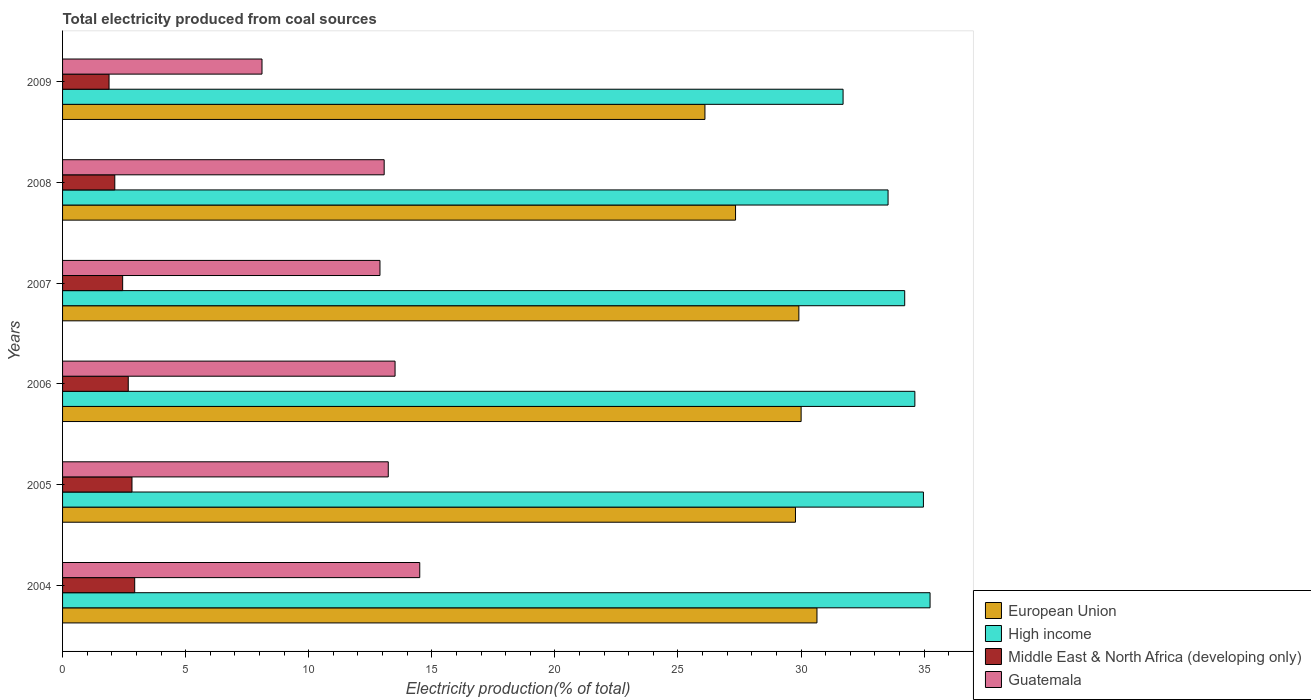Are the number of bars per tick equal to the number of legend labels?
Make the answer very short. Yes. Are the number of bars on each tick of the Y-axis equal?
Keep it short and to the point. Yes. How many bars are there on the 1st tick from the top?
Your answer should be very brief. 4. What is the label of the 3rd group of bars from the top?
Provide a short and direct response. 2007. What is the total electricity produced in European Union in 2009?
Ensure brevity in your answer.  26.1. Across all years, what is the maximum total electricity produced in Middle East & North Africa (developing only)?
Your answer should be compact. 2.93. Across all years, what is the minimum total electricity produced in High income?
Ensure brevity in your answer.  31.71. In which year was the total electricity produced in Guatemala minimum?
Ensure brevity in your answer.  2009. What is the total total electricity produced in Middle East & North Africa (developing only) in the graph?
Make the answer very short. 14.87. What is the difference between the total electricity produced in European Union in 2007 and that in 2009?
Keep it short and to the point. 3.82. What is the difference between the total electricity produced in High income in 2004 and the total electricity produced in European Union in 2005?
Provide a succinct answer. 5.47. What is the average total electricity produced in Middle East & North Africa (developing only) per year?
Your answer should be compact. 2.48. In the year 2008, what is the difference between the total electricity produced in European Union and total electricity produced in Middle East & North Africa (developing only)?
Your response must be concise. 25.22. In how many years, is the total electricity produced in High income greater than 17 %?
Keep it short and to the point. 6. What is the ratio of the total electricity produced in Guatemala in 2006 to that in 2007?
Make the answer very short. 1.05. What is the difference between the highest and the second highest total electricity produced in European Union?
Make the answer very short. 0.64. What is the difference between the highest and the lowest total electricity produced in European Union?
Offer a terse response. 4.55. Is the sum of the total electricity produced in Middle East & North Africa (developing only) in 2004 and 2005 greater than the maximum total electricity produced in Guatemala across all years?
Keep it short and to the point. No. How many years are there in the graph?
Ensure brevity in your answer.  6. Does the graph contain any zero values?
Provide a short and direct response. No. Where does the legend appear in the graph?
Your response must be concise. Bottom right. How many legend labels are there?
Your answer should be compact. 4. How are the legend labels stacked?
Your answer should be very brief. Vertical. What is the title of the graph?
Make the answer very short. Total electricity produced from coal sources. Does "Bermuda" appear as one of the legend labels in the graph?
Your response must be concise. No. What is the Electricity production(% of total) of European Union in 2004?
Ensure brevity in your answer.  30.65. What is the Electricity production(% of total) of High income in 2004?
Your answer should be very brief. 35.24. What is the Electricity production(% of total) in Middle East & North Africa (developing only) in 2004?
Offer a very short reply. 2.93. What is the Electricity production(% of total) of Guatemala in 2004?
Provide a short and direct response. 14.51. What is the Electricity production(% of total) of European Union in 2005?
Give a very brief answer. 29.77. What is the Electricity production(% of total) of High income in 2005?
Give a very brief answer. 34.97. What is the Electricity production(% of total) in Middle East & North Africa (developing only) in 2005?
Provide a short and direct response. 2.82. What is the Electricity production(% of total) of Guatemala in 2005?
Keep it short and to the point. 13.23. What is the Electricity production(% of total) in European Union in 2006?
Make the answer very short. 30. What is the Electricity production(% of total) of High income in 2006?
Give a very brief answer. 34.62. What is the Electricity production(% of total) in Middle East & North Africa (developing only) in 2006?
Keep it short and to the point. 2.67. What is the Electricity production(% of total) in Guatemala in 2006?
Offer a terse response. 13.51. What is the Electricity production(% of total) of European Union in 2007?
Your response must be concise. 29.91. What is the Electricity production(% of total) of High income in 2007?
Make the answer very short. 34.21. What is the Electricity production(% of total) in Middle East & North Africa (developing only) in 2007?
Give a very brief answer. 2.44. What is the Electricity production(% of total) in Guatemala in 2007?
Your response must be concise. 12.89. What is the Electricity production(% of total) of European Union in 2008?
Provide a short and direct response. 27.34. What is the Electricity production(% of total) of High income in 2008?
Make the answer very short. 33.54. What is the Electricity production(% of total) of Middle East & North Africa (developing only) in 2008?
Give a very brief answer. 2.12. What is the Electricity production(% of total) in Guatemala in 2008?
Offer a very short reply. 13.06. What is the Electricity production(% of total) in European Union in 2009?
Ensure brevity in your answer.  26.1. What is the Electricity production(% of total) in High income in 2009?
Offer a very short reply. 31.71. What is the Electricity production(% of total) in Middle East & North Africa (developing only) in 2009?
Offer a terse response. 1.89. What is the Electricity production(% of total) of Guatemala in 2009?
Give a very brief answer. 8.1. Across all years, what is the maximum Electricity production(% of total) of European Union?
Keep it short and to the point. 30.65. Across all years, what is the maximum Electricity production(% of total) of High income?
Provide a short and direct response. 35.24. Across all years, what is the maximum Electricity production(% of total) in Middle East & North Africa (developing only)?
Provide a short and direct response. 2.93. Across all years, what is the maximum Electricity production(% of total) in Guatemala?
Provide a short and direct response. 14.51. Across all years, what is the minimum Electricity production(% of total) of European Union?
Provide a succinct answer. 26.1. Across all years, what is the minimum Electricity production(% of total) of High income?
Your answer should be compact. 31.71. Across all years, what is the minimum Electricity production(% of total) of Middle East & North Africa (developing only)?
Your response must be concise. 1.89. Across all years, what is the minimum Electricity production(% of total) of Guatemala?
Give a very brief answer. 8.1. What is the total Electricity production(% of total) in European Union in the graph?
Offer a very short reply. 173.77. What is the total Electricity production(% of total) of High income in the graph?
Make the answer very short. 204.29. What is the total Electricity production(% of total) of Middle East & North Africa (developing only) in the graph?
Make the answer very short. 14.87. What is the total Electricity production(% of total) in Guatemala in the graph?
Make the answer very short. 75.31. What is the difference between the Electricity production(% of total) in European Union in 2004 and that in 2005?
Keep it short and to the point. 0.87. What is the difference between the Electricity production(% of total) of High income in 2004 and that in 2005?
Ensure brevity in your answer.  0.27. What is the difference between the Electricity production(% of total) of Middle East & North Africa (developing only) in 2004 and that in 2005?
Provide a succinct answer. 0.11. What is the difference between the Electricity production(% of total) in Guatemala in 2004 and that in 2005?
Ensure brevity in your answer.  1.28. What is the difference between the Electricity production(% of total) of European Union in 2004 and that in 2006?
Your response must be concise. 0.64. What is the difference between the Electricity production(% of total) in High income in 2004 and that in 2006?
Offer a very short reply. 0.62. What is the difference between the Electricity production(% of total) of Middle East & North Africa (developing only) in 2004 and that in 2006?
Provide a succinct answer. 0.26. What is the difference between the Electricity production(% of total) of European Union in 2004 and that in 2007?
Your answer should be compact. 0.74. What is the difference between the Electricity production(% of total) in High income in 2004 and that in 2007?
Make the answer very short. 1.03. What is the difference between the Electricity production(% of total) in Middle East & North Africa (developing only) in 2004 and that in 2007?
Your answer should be compact. 0.49. What is the difference between the Electricity production(% of total) of Guatemala in 2004 and that in 2007?
Your answer should be very brief. 1.62. What is the difference between the Electricity production(% of total) of European Union in 2004 and that in 2008?
Offer a very short reply. 3.31. What is the difference between the Electricity production(% of total) in High income in 2004 and that in 2008?
Your answer should be very brief. 1.71. What is the difference between the Electricity production(% of total) of Middle East & North Africa (developing only) in 2004 and that in 2008?
Provide a short and direct response. 0.81. What is the difference between the Electricity production(% of total) in Guatemala in 2004 and that in 2008?
Offer a terse response. 1.45. What is the difference between the Electricity production(% of total) in European Union in 2004 and that in 2009?
Give a very brief answer. 4.55. What is the difference between the Electricity production(% of total) of High income in 2004 and that in 2009?
Your answer should be compact. 3.53. What is the difference between the Electricity production(% of total) in Middle East & North Africa (developing only) in 2004 and that in 2009?
Offer a very short reply. 1.04. What is the difference between the Electricity production(% of total) of Guatemala in 2004 and that in 2009?
Offer a terse response. 6.41. What is the difference between the Electricity production(% of total) in European Union in 2005 and that in 2006?
Your answer should be very brief. -0.23. What is the difference between the Electricity production(% of total) of High income in 2005 and that in 2006?
Ensure brevity in your answer.  0.35. What is the difference between the Electricity production(% of total) in Middle East & North Africa (developing only) in 2005 and that in 2006?
Your response must be concise. 0.15. What is the difference between the Electricity production(% of total) in Guatemala in 2005 and that in 2006?
Offer a very short reply. -0.28. What is the difference between the Electricity production(% of total) in European Union in 2005 and that in 2007?
Keep it short and to the point. -0.14. What is the difference between the Electricity production(% of total) in High income in 2005 and that in 2007?
Give a very brief answer. 0.76. What is the difference between the Electricity production(% of total) of Middle East & North Africa (developing only) in 2005 and that in 2007?
Make the answer very short. 0.38. What is the difference between the Electricity production(% of total) of Guatemala in 2005 and that in 2007?
Your answer should be very brief. 0.34. What is the difference between the Electricity production(% of total) in European Union in 2005 and that in 2008?
Keep it short and to the point. 2.43. What is the difference between the Electricity production(% of total) of High income in 2005 and that in 2008?
Keep it short and to the point. 1.44. What is the difference between the Electricity production(% of total) of Middle East & North Africa (developing only) in 2005 and that in 2008?
Make the answer very short. 0.7. What is the difference between the Electricity production(% of total) of Guatemala in 2005 and that in 2008?
Keep it short and to the point. 0.17. What is the difference between the Electricity production(% of total) in European Union in 2005 and that in 2009?
Your response must be concise. 3.68. What is the difference between the Electricity production(% of total) in High income in 2005 and that in 2009?
Offer a terse response. 3.26. What is the difference between the Electricity production(% of total) of Middle East & North Africa (developing only) in 2005 and that in 2009?
Your answer should be very brief. 0.93. What is the difference between the Electricity production(% of total) of Guatemala in 2005 and that in 2009?
Offer a very short reply. 5.13. What is the difference between the Electricity production(% of total) in European Union in 2006 and that in 2007?
Your answer should be compact. 0.09. What is the difference between the Electricity production(% of total) of High income in 2006 and that in 2007?
Keep it short and to the point. 0.41. What is the difference between the Electricity production(% of total) in Middle East & North Africa (developing only) in 2006 and that in 2007?
Provide a short and direct response. 0.23. What is the difference between the Electricity production(% of total) in Guatemala in 2006 and that in 2007?
Offer a terse response. 0.61. What is the difference between the Electricity production(% of total) of European Union in 2006 and that in 2008?
Your answer should be compact. 2.66. What is the difference between the Electricity production(% of total) of High income in 2006 and that in 2008?
Make the answer very short. 1.09. What is the difference between the Electricity production(% of total) of Middle East & North Africa (developing only) in 2006 and that in 2008?
Make the answer very short. 0.55. What is the difference between the Electricity production(% of total) in Guatemala in 2006 and that in 2008?
Ensure brevity in your answer.  0.44. What is the difference between the Electricity production(% of total) of European Union in 2006 and that in 2009?
Provide a succinct answer. 3.91. What is the difference between the Electricity production(% of total) in High income in 2006 and that in 2009?
Provide a short and direct response. 2.92. What is the difference between the Electricity production(% of total) of Middle East & North Africa (developing only) in 2006 and that in 2009?
Keep it short and to the point. 0.78. What is the difference between the Electricity production(% of total) in Guatemala in 2006 and that in 2009?
Provide a succinct answer. 5.41. What is the difference between the Electricity production(% of total) of European Union in 2007 and that in 2008?
Your answer should be compact. 2.57. What is the difference between the Electricity production(% of total) in High income in 2007 and that in 2008?
Ensure brevity in your answer.  0.68. What is the difference between the Electricity production(% of total) of Middle East & North Africa (developing only) in 2007 and that in 2008?
Give a very brief answer. 0.32. What is the difference between the Electricity production(% of total) of Guatemala in 2007 and that in 2008?
Make the answer very short. -0.17. What is the difference between the Electricity production(% of total) of European Union in 2007 and that in 2009?
Ensure brevity in your answer.  3.82. What is the difference between the Electricity production(% of total) of High income in 2007 and that in 2009?
Keep it short and to the point. 2.5. What is the difference between the Electricity production(% of total) of Middle East & North Africa (developing only) in 2007 and that in 2009?
Give a very brief answer. 0.55. What is the difference between the Electricity production(% of total) of Guatemala in 2007 and that in 2009?
Your answer should be compact. 4.79. What is the difference between the Electricity production(% of total) of European Union in 2008 and that in 2009?
Offer a very short reply. 1.24. What is the difference between the Electricity production(% of total) in High income in 2008 and that in 2009?
Offer a very short reply. 1.83. What is the difference between the Electricity production(% of total) of Middle East & North Africa (developing only) in 2008 and that in 2009?
Ensure brevity in your answer.  0.23. What is the difference between the Electricity production(% of total) of Guatemala in 2008 and that in 2009?
Your answer should be compact. 4.96. What is the difference between the Electricity production(% of total) of European Union in 2004 and the Electricity production(% of total) of High income in 2005?
Your response must be concise. -4.33. What is the difference between the Electricity production(% of total) in European Union in 2004 and the Electricity production(% of total) in Middle East & North Africa (developing only) in 2005?
Provide a succinct answer. 27.83. What is the difference between the Electricity production(% of total) in European Union in 2004 and the Electricity production(% of total) in Guatemala in 2005?
Keep it short and to the point. 17.42. What is the difference between the Electricity production(% of total) in High income in 2004 and the Electricity production(% of total) in Middle East & North Africa (developing only) in 2005?
Ensure brevity in your answer.  32.42. What is the difference between the Electricity production(% of total) of High income in 2004 and the Electricity production(% of total) of Guatemala in 2005?
Your answer should be compact. 22.01. What is the difference between the Electricity production(% of total) of Middle East & North Africa (developing only) in 2004 and the Electricity production(% of total) of Guatemala in 2005?
Your response must be concise. -10.3. What is the difference between the Electricity production(% of total) in European Union in 2004 and the Electricity production(% of total) in High income in 2006?
Make the answer very short. -3.98. What is the difference between the Electricity production(% of total) in European Union in 2004 and the Electricity production(% of total) in Middle East & North Africa (developing only) in 2006?
Provide a succinct answer. 27.98. What is the difference between the Electricity production(% of total) in European Union in 2004 and the Electricity production(% of total) in Guatemala in 2006?
Offer a very short reply. 17.14. What is the difference between the Electricity production(% of total) in High income in 2004 and the Electricity production(% of total) in Middle East & North Africa (developing only) in 2006?
Give a very brief answer. 32.57. What is the difference between the Electricity production(% of total) of High income in 2004 and the Electricity production(% of total) of Guatemala in 2006?
Keep it short and to the point. 21.73. What is the difference between the Electricity production(% of total) in Middle East & North Africa (developing only) in 2004 and the Electricity production(% of total) in Guatemala in 2006?
Ensure brevity in your answer.  -10.58. What is the difference between the Electricity production(% of total) in European Union in 2004 and the Electricity production(% of total) in High income in 2007?
Offer a very short reply. -3.56. What is the difference between the Electricity production(% of total) of European Union in 2004 and the Electricity production(% of total) of Middle East & North Africa (developing only) in 2007?
Make the answer very short. 28.21. What is the difference between the Electricity production(% of total) of European Union in 2004 and the Electricity production(% of total) of Guatemala in 2007?
Your answer should be very brief. 17.75. What is the difference between the Electricity production(% of total) of High income in 2004 and the Electricity production(% of total) of Middle East & North Africa (developing only) in 2007?
Your answer should be very brief. 32.8. What is the difference between the Electricity production(% of total) of High income in 2004 and the Electricity production(% of total) of Guatemala in 2007?
Your answer should be very brief. 22.35. What is the difference between the Electricity production(% of total) of Middle East & North Africa (developing only) in 2004 and the Electricity production(% of total) of Guatemala in 2007?
Your answer should be very brief. -9.96. What is the difference between the Electricity production(% of total) of European Union in 2004 and the Electricity production(% of total) of High income in 2008?
Your answer should be compact. -2.89. What is the difference between the Electricity production(% of total) of European Union in 2004 and the Electricity production(% of total) of Middle East & North Africa (developing only) in 2008?
Ensure brevity in your answer.  28.53. What is the difference between the Electricity production(% of total) of European Union in 2004 and the Electricity production(% of total) of Guatemala in 2008?
Keep it short and to the point. 17.58. What is the difference between the Electricity production(% of total) in High income in 2004 and the Electricity production(% of total) in Middle East & North Africa (developing only) in 2008?
Your answer should be compact. 33.12. What is the difference between the Electricity production(% of total) in High income in 2004 and the Electricity production(% of total) in Guatemala in 2008?
Offer a terse response. 22.18. What is the difference between the Electricity production(% of total) of Middle East & North Africa (developing only) in 2004 and the Electricity production(% of total) of Guatemala in 2008?
Make the answer very short. -10.13. What is the difference between the Electricity production(% of total) in European Union in 2004 and the Electricity production(% of total) in High income in 2009?
Your answer should be very brief. -1.06. What is the difference between the Electricity production(% of total) in European Union in 2004 and the Electricity production(% of total) in Middle East & North Africa (developing only) in 2009?
Your response must be concise. 28.76. What is the difference between the Electricity production(% of total) in European Union in 2004 and the Electricity production(% of total) in Guatemala in 2009?
Offer a terse response. 22.54. What is the difference between the Electricity production(% of total) of High income in 2004 and the Electricity production(% of total) of Middle East & North Africa (developing only) in 2009?
Give a very brief answer. 33.35. What is the difference between the Electricity production(% of total) of High income in 2004 and the Electricity production(% of total) of Guatemala in 2009?
Your answer should be compact. 27.14. What is the difference between the Electricity production(% of total) of Middle East & North Africa (developing only) in 2004 and the Electricity production(% of total) of Guatemala in 2009?
Your answer should be very brief. -5.17. What is the difference between the Electricity production(% of total) of European Union in 2005 and the Electricity production(% of total) of High income in 2006?
Offer a terse response. -4.85. What is the difference between the Electricity production(% of total) of European Union in 2005 and the Electricity production(% of total) of Middle East & North Africa (developing only) in 2006?
Provide a succinct answer. 27.11. What is the difference between the Electricity production(% of total) in European Union in 2005 and the Electricity production(% of total) in Guatemala in 2006?
Provide a succinct answer. 16.27. What is the difference between the Electricity production(% of total) in High income in 2005 and the Electricity production(% of total) in Middle East & North Africa (developing only) in 2006?
Offer a very short reply. 32.3. What is the difference between the Electricity production(% of total) in High income in 2005 and the Electricity production(% of total) in Guatemala in 2006?
Ensure brevity in your answer.  21.46. What is the difference between the Electricity production(% of total) in Middle East & North Africa (developing only) in 2005 and the Electricity production(% of total) in Guatemala in 2006?
Your answer should be compact. -10.69. What is the difference between the Electricity production(% of total) in European Union in 2005 and the Electricity production(% of total) in High income in 2007?
Offer a very short reply. -4.44. What is the difference between the Electricity production(% of total) in European Union in 2005 and the Electricity production(% of total) in Middle East & North Africa (developing only) in 2007?
Your answer should be compact. 27.33. What is the difference between the Electricity production(% of total) of European Union in 2005 and the Electricity production(% of total) of Guatemala in 2007?
Your answer should be very brief. 16.88. What is the difference between the Electricity production(% of total) of High income in 2005 and the Electricity production(% of total) of Middle East & North Africa (developing only) in 2007?
Make the answer very short. 32.53. What is the difference between the Electricity production(% of total) of High income in 2005 and the Electricity production(% of total) of Guatemala in 2007?
Give a very brief answer. 22.08. What is the difference between the Electricity production(% of total) in Middle East & North Africa (developing only) in 2005 and the Electricity production(% of total) in Guatemala in 2007?
Your answer should be very brief. -10.07. What is the difference between the Electricity production(% of total) of European Union in 2005 and the Electricity production(% of total) of High income in 2008?
Your answer should be compact. -3.76. What is the difference between the Electricity production(% of total) in European Union in 2005 and the Electricity production(% of total) in Middle East & North Africa (developing only) in 2008?
Keep it short and to the point. 27.65. What is the difference between the Electricity production(% of total) of European Union in 2005 and the Electricity production(% of total) of Guatemala in 2008?
Your answer should be very brief. 16.71. What is the difference between the Electricity production(% of total) in High income in 2005 and the Electricity production(% of total) in Middle East & North Africa (developing only) in 2008?
Make the answer very short. 32.85. What is the difference between the Electricity production(% of total) in High income in 2005 and the Electricity production(% of total) in Guatemala in 2008?
Ensure brevity in your answer.  21.91. What is the difference between the Electricity production(% of total) in Middle East & North Africa (developing only) in 2005 and the Electricity production(% of total) in Guatemala in 2008?
Make the answer very short. -10.24. What is the difference between the Electricity production(% of total) in European Union in 2005 and the Electricity production(% of total) in High income in 2009?
Provide a short and direct response. -1.93. What is the difference between the Electricity production(% of total) of European Union in 2005 and the Electricity production(% of total) of Middle East & North Africa (developing only) in 2009?
Make the answer very short. 27.89. What is the difference between the Electricity production(% of total) of European Union in 2005 and the Electricity production(% of total) of Guatemala in 2009?
Provide a short and direct response. 21.67. What is the difference between the Electricity production(% of total) in High income in 2005 and the Electricity production(% of total) in Middle East & North Africa (developing only) in 2009?
Provide a succinct answer. 33.08. What is the difference between the Electricity production(% of total) in High income in 2005 and the Electricity production(% of total) in Guatemala in 2009?
Give a very brief answer. 26.87. What is the difference between the Electricity production(% of total) of Middle East & North Africa (developing only) in 2005 and the Electricity production(% of total) of Guatemala in 2009?
Your response must be concise. -5.28. What is the difference between the Electricity production(% of total) of European Union in 2006 and the Electricity production(% of total) of High income in 2007?
Ensure brevity in your answer.  -4.21. What is the difference between the Electricity production(% of total) in European Union in 2006 and the Electricity production(% of total) in Middle East & North Africa (developing only) in 2007?
Provide a succinct answer. 27.56. What is the difference between the Electricity production(% of total) of European Union in 2006 and the Electricity production(% of total) of Guatemala in 2007?
Provide a succinct answer. 17.11. What is the difference between the Electricity production(% of total) in High income in 2006 and the Electricity production(% of total) in Middle East & North Africa (developing only) in 2007?
Ensure brevity in your answer.  32.18. What is the difference between the Electricity production(% of total) in High income in 2006 and the Electricity production(% of total) in Guatemala in 2007?
Provide a short and direct response. 21.73. What is the difference between the Electricity production(% of total) of Middle East & North Africa (developing only) in 2006 and the Electricity production(% of total) of Guatemala in 2007?
Your response must be concise. -10.23. What is the difference between the Electricity production(% of total) in European Union in 2006 and the Electricity production(% of total) in High income in 2008?
Your answer should be very brief. -3.53. What is the difference between the Electricity production(% of total) of European Union in 2006 and the Electricity production(% of total) of Middle East & North Africa (developing only) in 2008?
Give a very brief answer. 27.88. What is the difference between the Electricity production(% of total) of European Union in 2006 and the Electricity production(% of total) of Guatemala in 2008?
Make the answer very short. 16.94. What is the difference between the Electricity production(% of total) of High income in 2006 and the Electricity production(% of total) of Middle East & North Africa (developing only) in 2008?
Ensure brevity in your answer.  32.5. What is the difference between the Electricity production(% of total) in High income in 2006 and the Electricity production(% of total) in Guatemala in 2008?
Your answer should be compact. 21.56. What is the difference between the Electricity production(% of total) of Middle East & North Africa (developing only) in 2006 and the Electricity production(% of total) of Guatemala in 2008?
Offer a very short reply. -10.4. What is the difference between the Electricity production(% of total) in European Union in 2006 and the Electricity production(% of total) in High income in 2009?
Provide a succinct answer. -1.7. What is the difference between the Electricity production(% of total) of European Union in 2006 and the Electricity production(% of total) of Middle East & North Africa (developing only) in 2009?
Provide a succinct answer. 28.12. What is the difference between the Electricity production(% of total) of European Union in 2006 and the Electricity production(% of total) of Guatemala in 2009?
Offer a very short reply. 21.9. What is the difference between the Electricity production(% of total) of High income in 2006 and the Electricity production(% of total) of Middle East & North Africa (developing only) in 2009?
Your answer should be compact. 32.74. What is the difference between the Electricity production(% of total) in High income in 2006 and the Electricity production(% of total) in Guatemala in 2009?
Make the answer very short. 26.52. What is the difference between the Electricity production(% of total) in Middle East & North Africa (developing only) in 2006 and the Electricity production(% of total) in Guatemala in 2009?
Your response must be concise. -5.43. What is the difference between the Electricity production(% of total) of European Union in 2007 and the Electricity production(% of total) of High income in 2008?
Ensure brevity in your answer.  -3.62. What is the difference between the Electricity production(% of total) in European Union in 2007 and the Electricity production(% of total) in Middle East & North Africa (developing only) in 2008?
Provide a succinct answer. 27.79. What is the difference between the Electricity production(% of total) of European Union in 2007 and the Electricity production(% of total) of Guatemala in 2008?
Make the answer very short. 16.85. What is the difference between the Electricity production(% of total) in High income in 2007 and the Electricity production(% of total) in Middle East & North Africa (developing only) in 2008?
Your answer should be compact. 32.09. What is the difference between the Electricity production(% of total) of High income in 2007 and the Electricity production(% of total) of Guatemala in 2008?
Offer a very short reply. 21.15. What is the difference between the Electricity production(% of total) in Middle East & North Africa (developing only) in 2007 and the Electricity production(% of total) in Guatemala in 2008?
Offer a very short reply. -10.62. What is the difference between the Electricity production(% of total) of European Union in 2007 and the Electricity production(% of total) of High income in 2009?
Offer a terse response. -1.8. What is the difference between the Electricity production(% of total) in European Union in 2007 and the Electricity production(% of total) in Middle East & North Africa (developing only) in 2009?
Give a very brief answer. 28.02. What is the difference between the Electricity production(% of total) in European Union in 2007 and the Electricity production(% of total) in Guatemala in 2009?
Offer a very short reply. 21.81. What is the difference between the Electricity production(% of total) of High income in 2007 and the Electricity production(% of total) of Middle East & North Africa (developing only) in 2009?
Offer a terse response. 32.32. What is the difference between the Electricity production(% of total) of High income in 2007 and the Electricity production(% of total) of Guatemala in 2009?
Offer a very short reply. 26.11. What is the difference between the Electricity production(% of total) in Middle East & North Africa (developing only) in 2007 and the Electricity production(% of total) in Guatemala in 2009?
Keep it short and to the point. -5.66. What is the difference between the Electricity production(% of total) of European Union in 2008 and the Electricity production(% of total) of High income in 2009?
Offer a very short reply. -4.37. What is the difference between the Electricity production(% of total) of European Union in 2008 and the Electricity production(% of total) of Middle East & North Africa (developing only) in 2009?
Offer a terse response. 25.45. What is the difference between the Electricity production(% of total) in European Union in 2008 and the Electricity production(% of total) in Guatemala in 2009?
Give a very brief answer. 19.24. What is the difference between the Electricity production(% of total) of High income in 2008 and the Electricity production(% of total) of Middle East & North Africa (developing only) in 2009?
Your answer should be compact. 31.65. What is the difference between the Electricity production(% of total) of High income in 2008 and the Electricity production(% of total) of Guatemala in 2009?
Provide a short and direct response. 25.43. What is the difference between the Electricity production(% of total) in Middle East & North Africa (developing only) in 2008 and the Electricity production(% of total) in Guatemala in 2009?
Make the answer very short. -5.98. What is the average Electricity production(% of total) in European Union per year?
Provide a succinct answer. 28.96. What is the average Electricity production(% of total) of High income per year?
Offer a very short reply. 34.05. What is the average Electricity production(% of total) in Middle East & North Africa (developing only) per year?
Ensure brevity in your answer.  2.48. What is the average Electricity production(% of total) of Guatemala per year?
Ensure brevity in your answer.  12.55. In the year 2004, what is the difference between the Electricity production(% of total) of European Union and Electricity production(% of total) of High income?
Your answer should be very brief. -4.59. In the year 2004, what is the difference between the Electricity production(% of total) of European Union and Electricity production(% of total) of Middle East & North Africa (developing only)?
Make the answer very short. 27.72. In the year 2004, what is the difference between the Electricity production(% of total) in European Union and Electricity production(% of total) in Guatemala?
Provide a short and direct response. 16.14. In the year 2004, what is the difference between the Electricity production(% of total) in High income and Electricity production(% of total) in Middle East & North Africa (developing only)?
Ensure brevity in your answer.  32.31. In the year 2004, what is the difference between the Electricity production(% of total) of High income and Electricity production(% of total) of Guatemala?
Offer a very short reply. 20.73. In the year 2004, what is the difference between the Electricity production(% of total) in Middle East & North Africa (developing only) and Electricity production(% of total) in Guatemala?
Your response must be concise. -11.58. In the year 2005, what is the difference between the Electricity production(% of total) in European Union and Electricity production(% of total) in High income?
Offer a very short reply. -5.2. In the year 2005, what is the difference between the Electricity production(% of total) of European Union and Electricity production(% of total) of Middle East & North Africa (developing only)?
Give a very brief answer. 26.95. In the year 2005, what is the difference between the Electricity production(% of total) in European Union and Electricity production(% of total) in Guatemala?
Keep it short and to the point. 16.54. In the year 2005, what is the difference between the Electricity production(% of total) in High income and Electricity production(% of total) in Middle East & North Africa (developing only)?
Your response must be concise. 32.15. In the year 2005, what is the difference between the Electricity production(% of total) of High income and Electricity production(% of total) of Guatemala?
Provide a short and direct response. 21.74. In the year 2005, what is the difference between the Electricity production(% of total) of Middle East & North Africa (developing only) and Electricity production(% of total) of Guatemala?
Your answer should be very brief. -10.41. In the year 2006, what is the difference between the Electricity production(% of total) in European Union and Electricity production(% of total) in High income?
Keep it short and to the point. -4.62. In the year 2006, what is the difference between the Electricity production(% of total) of European Union and Electricity production(% of total) of Middle East & North Africa (developing only)?
Offer a terse response. 27.34. In the year 2006, what is the difference between the Electricity production(% of total) in European Union and Electricity production(% of total) in Guatemala?
Make the answer very short. 16.5. In the year 2006, what is the difference between the Electricity production(% of total) of High income and Electricity production(% of total) of Middle East & North Africa (developing only)?
Your response must be concise. 31.96. In the year 2006, what is the difference between the Electricity production(% of total) of High income and Electricity production(% of total) of Guatemala?
Give a very brief answer. 21.12. In the year 2006, what is the difference between the Electricity production(% of total) of Middle East & North Africa (developing only) and Electricity production(% of total) of Guatemala?
Offer a terse response. -10.84. In the year 2007, what is the difference between the Electricity production(% of total) in European Union and Electricity production(% of total) in High income?
Provide a succinct answer. -4.3. In the year 2007, what is the difference between the Electricity production(% of total) in European Union and Electricity production(% of total) in Middle East & North Africa (developing only)?
Your response must be concise. 27.47. In the year 2007, what is the difference between the Electricity production(% of total) in European Union and Electricity production(% of total) in Guatemala?
Offer a terse response. 17.02. In the year 2007, what is the difference between the Electricity production(% of total) of High income and Electricity production(% of total) of Middle East & North Africa (developing only)?
Give a very brief answer. 31.77. In the year 2007, what is the difference between the Electricity production(% of total) of High income and Electricity production(% of total) of Guatemala?
Give a very brief answer. 21.32. In the year 2007, what is the difference between the Electricity production(% of total) in Middle East & North Africa (developing only) and Electricity production(% of total) in Guatemala?
Give a very brief answer. -10.45. In the year 2008, what is the difference between the Electricity production(% of total) in European Union and Electricity production(% of total) in High income?
Give a very brief answer. -6.2. In the year 2008, what is the difference between the Electricity production(% of total) in European Union and Electricity production(% of total) in Middle East & North Africa (developing only)?
Make the answer very short. 25.22. In the year 2008, what is the difference between the Electricity production(% of total) in European Union and Electricity production(% of total) in Guatemala?
Your answer should be compact. 14.27. In the year 2008, what is the difference between the Electricity production(% of total) in High income and Electricity production(% of total) in Middle East & North Africa (developing only)?
Your answer should be very brief. 31.41. In the year 2008, what is the difference between the Electricity production(% of total) of High income and Electricity production(% of total) of Guatemala?
Give a very brief answer. 20.47. In the year 2008, what is the difference between the Electricity production(% of total) in Middle East & North Africa (developing only) and Electricity production(% of total) in Guatemala?
Your response must be concise. -10.94. In the year 2009, what is the difference between the Electricity production(% of total) in European Union and Electricity production(% of total) in High income?
Give a very brief answer. -5.61. In the year 2009, what is the difference between the Electricity production(% of total) of European Union and Electricity production(% of total) of Middle East & North Africa (developing only)?
Your answer should be compact. 24.21. In the year 2009, what is the difference between the Electricity production(% of total) in European Union and Electricity production(% of total) in Guatemala?
Make the answer very short. 17.99. In the year 2009, what is the difference between the Electricity production(% of total) in High income and Electricity production(% of total) in Middle East & North Africa (developing only)?
Give a very brief answer. 29.82. In the year 2009, what is the difference between the Electricity production(% of total) in High income and Electricity production(% of total) in Guatemala?
Ensure brevity in your answer.  23.61. In the year 2009, what is the difference between the Electricity production(% of total) of Middle East & North Africa (developing only) and Electricity production(% of total) of Guatemala?
Ensure brevity in your answer.  -6.21. What is the ratio of the Electricity production(% of total) in European Union in 2004 to that in 2005?
Offer a terse response. 1.03. What is the ratio of the Electricity production(% of total) of High income in 2004 to that in 2005?
Ensure brevity in your answer.  1.01. What is the ratio of the Electricity production(% of total) of Middle East & North Africa (developing only) in 2004 to that in 2005?
Provide a short and direct response. 1.04. What is the ratio of the Electricity production(% of total) in Guatemala in 2004 to that in 2005?
Your response must be concise. 1.1. What is the ratio of the Electricity production(% of total) in European Union in 2004 to that in 2006?
Your answer should be compact. 1.02. What is the ratio of the Electricity production(% of total) in High income in 2004 to that in 2006?
Offer a terse response. 1.02. What is the ratio of the Electricity production(% of total) in Middle East & North Africa (developing only) in 2004 to that in 2006?
Offer a very short reply. 1.1. What is the ratio of the Electricity production(% of total) in Guatemala in 2004 to that in 2006?
Provide a succinct answer. 1.07. What is the ratio of the Electricity production(% of total) of European Union in 2004 to that in 2007?
Make the answer very short. 1.02. What is the ratio of the Electricity production(% of total) of High income in 2004 to that in 2007?
Provide a succinct answer. 1.03. What is the ratio of the Electricity production(% of total) in Middle East & North Africa (developing only) in 2004 to that in 2007?
Provide a succinct answer. 1.2. What is the ratio of the Electricity production(% of total) of Guatemala in 2004 to that in 2007?
Provide a short and direct response. 1.13. What is the ratio of the Electricity production(% of total) of European Union in 2004 to that in 2008?
Your answer should be compact. 1.12. What is the ratio of the Electricity production(% of total) of High income in 2004 to that in 2008?
Ensure brevity in your answer.  1.05. What is the ratio of the Electricity production(% of total) of Middle East & North Africa (developing only) in 2004 to that in 2008?
Provide a succinct answer. 1.38. What is the ratio of the Electricity production(% of total) of Guatemala in 2004 to that in 2008?
Make the answer very short. 1.11. What is the ratio of the Electricity production(% of total) of European Union in 2004 to that in 2009?
Provide a succinct answer. 1.17. What is the ratio of the Electricity production(% of total) in High income in 2004 to that in 2009?
Keep it short and to the point. 1.11. What is the ratio of the Electricity production(% of total) in Middle East & North Africa (developing only) in 2004 to that in 2009?
Ensure brevity in your answer.  1.55. What is the ratio of the Electricity production(% of total) in Guatemala in 2004 to that in 2009?
Keep it short and to the point. 1.79. What is the ratio of the Electricity production(% of total) of European Union in 2005 to that in 2006?
Your answer should be compact. 0.99. What is the ratio of the Electricity production(% of total) of Middle East & North Africa (developing only) in 2005 to that in 2006?
Give a very brief answer. 1.06. What is the ratio of the Electricity production(% of total) of Guatemala in 2005 to that in 2006?
Provide a short and direct response. 0.98. What is the ratio of the Electricity production(% of total) in European Union in 2005 to that in 2007?
Give a very brief answer. 1. What is the ratio of the Electricity production(% of total) of High income in 2005 to that in 2007?
Your answer should be very brief. 1.02. What is the ratio of the Electricity production(% of total) in Middle East & North Africa (developing only) in 2005 to that in 2007?
Make the answer very short. 1.16. What is the ratio of the Electricity production(% of total) in Guatemala in 2005 to that in 2007?
Provide a short and direct response. 1.03. What is the ratio of the Electricity production(% of total) in European Union in 2005 to that in 2008?
Keep it short and to the point. 1.09. What is the ratio of the Electricity production(% of total) of High income in 2005 to that in 2008?
Provide a succinct answer. 1.04. What is the ratio of the Electricity production(% of total) of Middle East & North Africa (developing only) in 2005 to that in 2008?
Provide a succinct answer. 1.33. What is the ratio of the Electricity production(% of total) of Guatemala in 2005 to that in 2008?
Ensure brevity in your answer.  1.01. What is the ratio of the Electricity production(% of total) of European Union in 2005 to that in 2009?
Your answer should be very brief. 1.14. What is the ratio of the Electricity production(% of total) of High income in 2005 to that in 2009?
Provide a succinct answer. 1.1. What is the ratio of the Electricity production(% of total) of Middle East & North Africa (developing only) in 2005 to that in 2009?
Provide a succinct answer. 1.49. What is the ratio of the Electricity production(% of total) in Guatemala in 2005 to that in 2009?
Ensure brevity in your answer.  1.63. What is the ratio of the Electricity production(% of total) in European Union in 2006 to that in 2007?
Provide a short and direct response. 1. What is the ratio of the Electricity production(% of total) of High income in 2006 to that in 2007?
Provide a succinct answer. 1.01. What is the ratio of the Electricity production(% of total) of Middle East & North Africa (developing only) in 2006 to that in 2007?
Your answer should be very brief. 1.09. What is the ratio of the Electricity production(% of total) of Guatemala in 2006 to that in 2007?
Keep it short and to the point. 1.05. What is the ratio of the Electricity production(% of total) of European Union in 2006 to that in 2008?
Provide a succinct answer. 1.1. What is the ratio of the Electricity production(% of total) in High income in 2006 to that in 2008?
Provide a short and direct response. 1.03. What is the ratio of the Electricity production(% of total) in Middle East & North Africa (developing only) in 2006 to that in 2008?
Your answer should be very brief. 1.26. What is the ratio of the Electricity production(% of total) of Guatemala in 2006 to that in 2008?
Your answer should be very brief. 1.03. What is the ratio of the Electricity production(% of total) in European Union in 2006 to that in 2009?
Your answer should be very brief. 1.15. What is the ratio of the Electricity production(% of total) in High income in 2006 to that in 2009?
Your response must be concise. 1.09. What is the ratio of the Electricity production(% of total) in Middle East & North Africa (developing only) in 2006 to that in 2009?
Provide a succinct answer. 1.41. What is the ratio of the Electricity production(% of total) of Guatemala in 2006 to that in 2009?
Provide a short and direct response. 1.67. What is the ratio of the Electricity production(% of total) of European Union in 2007 to that in 2008?
Ensure brevity in your answer.  1.09. What is the ratio of the Electricity production(% of total) of High income in 2007 to that in 2008?
Give a very brief answer. 1.02. What is the ratio of the Electricity production(% of total) in Middle East & North Africa (developing only) in 2007 to that in 2008?
Your response must be concise. 1.15. What is the ratio of the Electricity production(% of total) of Guatemala in 2007 to that in 2008?
Your answer should be very brief. 0.99. What is the ratio of the Electricity production(% of total) of European Union in 2007 to that in 2009?
Give a very brief answer. 1.15. What is the ratio of the Electricity production(% of total) of High income in 2007 to that in 2009?
Keep it short and to the point. 1.08. What is the ratio of the Electricity production(% of total) of Middle East & North Africa (developing only) in 2007 to that in 2009?
Offer a very short reply. 1.29. What is the ratio of the Electricity production(% of total) in Guatemala in 2007 to that in 2009?
Offer a terse response. 1.59. What is the ratio of the Electricity production(% of total) of European Union in 2008 to that in 2009?
Keep it short and to the point. 1.05. What is the ratio of the Electricity production(% of total) of High income in 2008 to that in 2009?
Offer a terse response. 1.06. What is the ratio of the Electricity production(% of total) of Middle East & North Africa (developing only) in 2008 to that in 2009?
Keep it short and to the point. 1.12. What is the ratio of the Electricity production(% of total) of Guatemala in 2008 to that in 2009?
Provide a succinct answer. 1.61. What is the difference between the highest and the second highest Electricity production(% of total) of European Union?
Your response must be concise. 0.64. What is the difference between the highest and the second highest Electricity production(% of total) of High income?
Offer a terse response. 0.27. What is the difference between the highest and the second highest Electricity production(% of total) of Middle East & North Africa (developing only)?
Provide a short and direct response. 0.11. What is the difference between the highest and the second highest Electricity production(% of total) in Guatemala?
Offer a very short reply. 1. What is the difference between the highest and the lowest Electricity production(% of total) of European Union?
Provide a short and direct response. 4.55. What is the difference between the highest and the lowest Electricity production(% of total) of High income?
Provide a short and direct response. 3.53. What is the difference between the highest and the lowest Electricity production(% of total) of Middle East & North Africa (developing only)?
Give a very brief answer. 1.04. What is the difference between the highest and the lowest Electricity production(% of total) in Guatemala?
Make the answer very short. 6.41. 